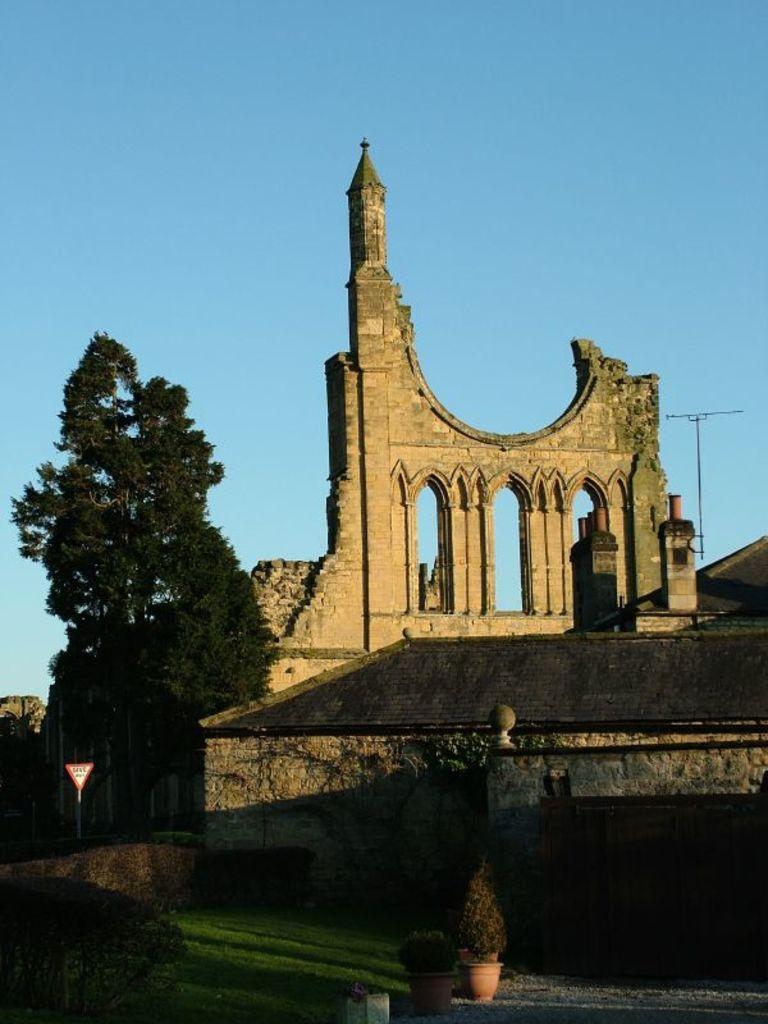Can you describe this image briefly? In this image we can see an ancient architecture. Also there is a tree. And there is a sign board with pole. On the ground there is grass. Also there are pots with plants. In the background there is sky. 